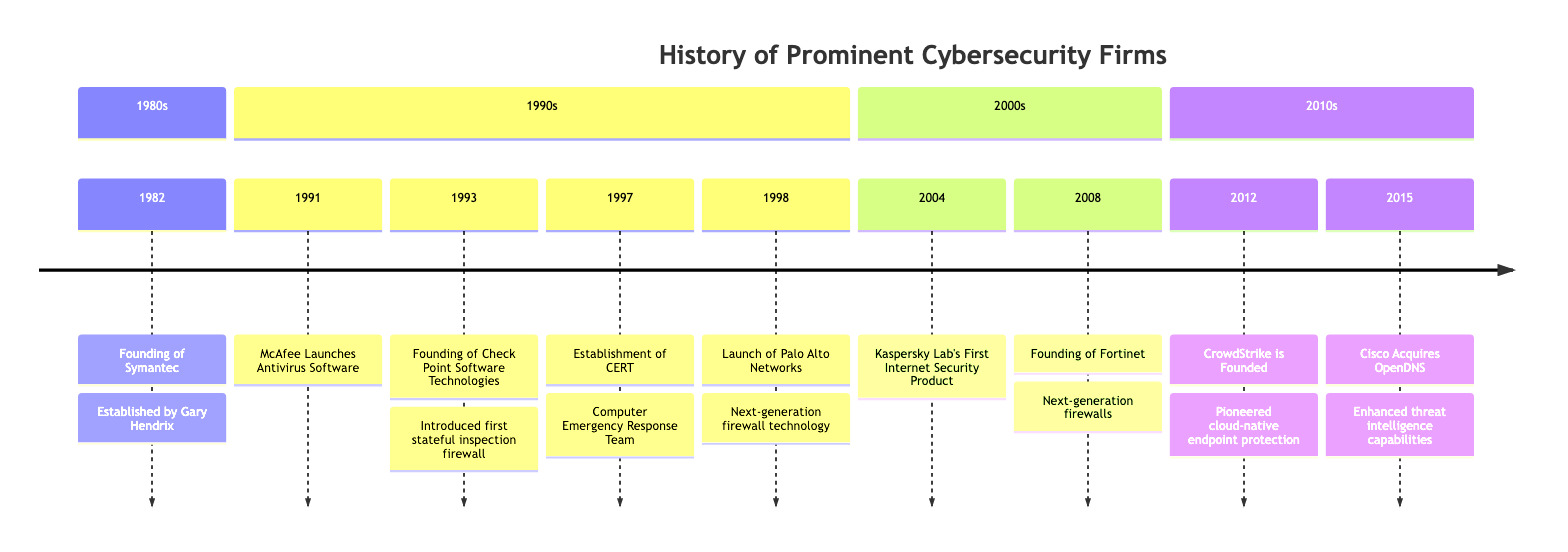What year was Symantec founded? The diagram indicates that Symantec was founded in the year 1982, as specified in the timeline.
Answer: 1982 What major achievement did McAfee accomplish in 1991? In the year 1991, McAfee launched its first antivirus software, marking a significant milestone for the company as noted in the diagram.
Answer: Launched antivirus software Which company was established in 1993? The timeline shows that Check Point Software Technologies was founded in 1993, as detailed in that section of the diagram.
Answer: Check Point Software Technologies What technology did Palo Alto Networks introduce? The diagram states that Palo Alto Networks launched next-generation firewall technology in 1998, highlighting their innovative approach to network security.
Answer: Next-generation firewall technology In what year was the Computer Emergency Response Team established? According to the timeline, the Computer Emergency Response Team (CERT) was established in 1997, providing a significant resource for cybersecurity threats.
Answer: 1997 What was a key focus of Fortinet when it was founded? The diagram notes that Fortinet was founded with an emphasis on developing next-generation firewalls, which indicates their focus on advanced security solutions from the outset.
Answer: Next-generation firewalls Which company launched its first comprehensive internet security product in 2004? The timeline specifies that Kaspersky Lab released its first comprehensive internet security product in 2004, marking a notable development in its product offerings.
Answer: Kaspersky Lab What was CrowdStrike known for in 2012? The timeline highlights that CrowdStrike pioneered cloud-native endpoint protection with the Falcon platform when it was founded in 2012, showcasing their innovative approach to cybersecurity.
Answer: Cloud-native endpoint protection Which company did Cisco acquire in 2015? The diagram clearly states that in 2015, Cisco acquired OpenDNS, which enhanced its capabilities in threat intelligence and domain security.
Answer: OpenDNS 